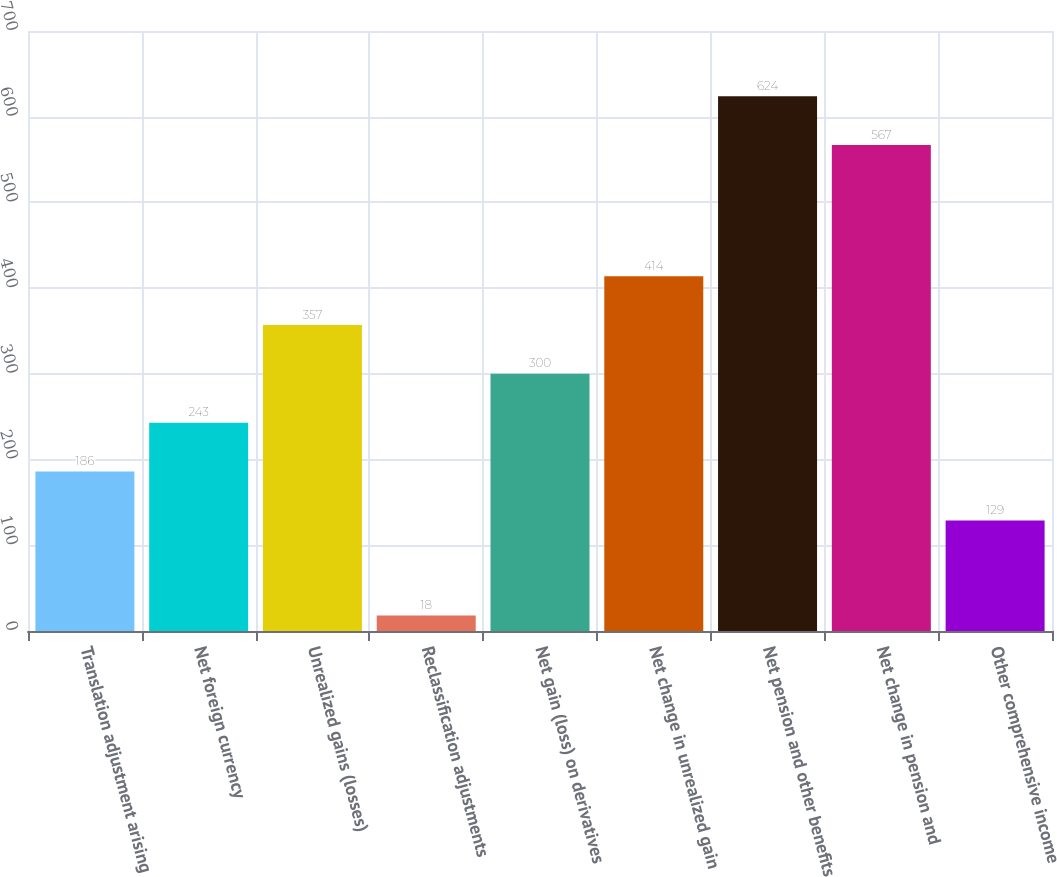<chart> <loc_0><loc_0><loc_500><loc_500><bar_chart><fcel>Translation adjustment arising<fcel>Net foreign currency<fcel>Unrealized gains (losses)<fcel>Reclassification adjustments<fcel>Net gain (loss) on derivatives<fcel>Net change in unrealized gain<fcel>Net pension and other benefits<fcel>Net change in pension and<fcel>Other comprehensive income<nl><fcel>186<fcel>243<fcel>357<fcel>18<fcel>300<fcel>414<fcel>624<fcel>567<fcel>129<nl></chart> 